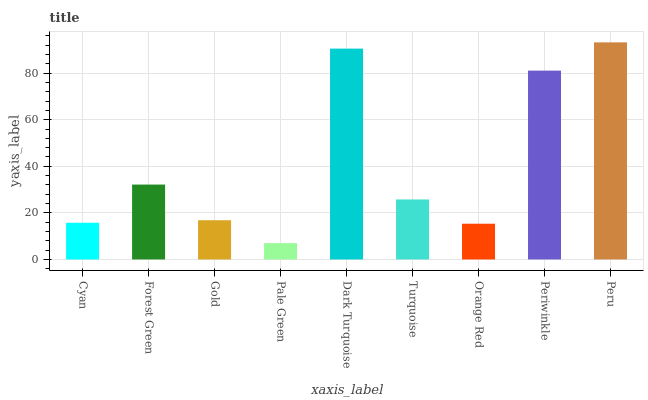Is Forest Green the minimum?
Answer yes or no. No. Is Forest Green the maximum?
Answer yes or no. No. Is Forest Green greater than Cyan?
Answer yes or no. Yes. Is Cyan less than Forest Green?
Answer yes or no. Yes. Is Cyan greater than Forest Green?
Answer yes or no. No. Is Forest Green less than Cyan?
Answer yes or no. No. Is Turquoise the high median?
Answer yes or no. Yes. Is Turquoise the low median?
Answer yes or no. Yes. Is Peru the high median?
Answer yes or no. No. Is Forest Green the low median?
Answer yes or no. No. 